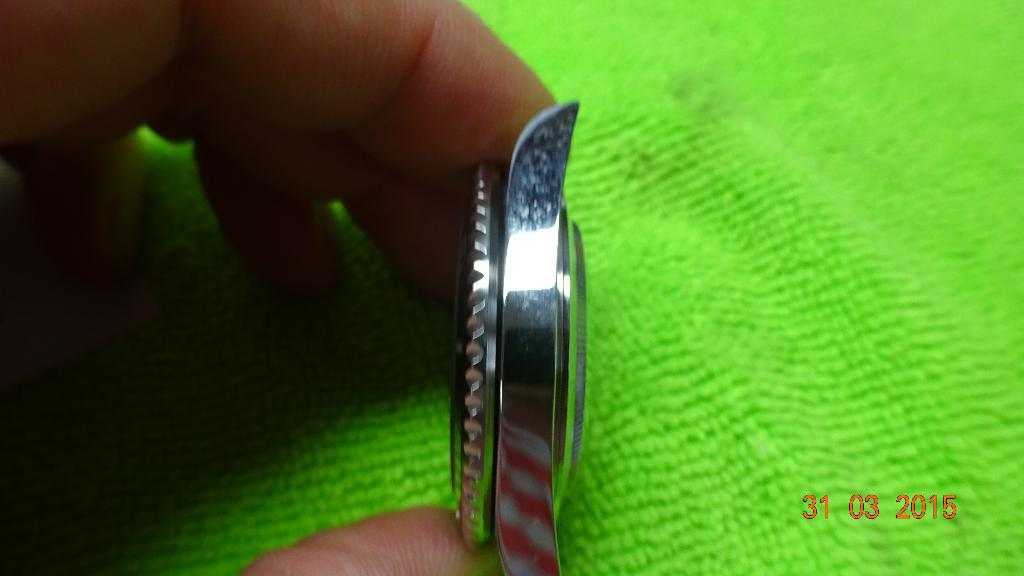Provide a one-sentence caption for the provided image. A watch is displayed from the side on March 3 2015. 